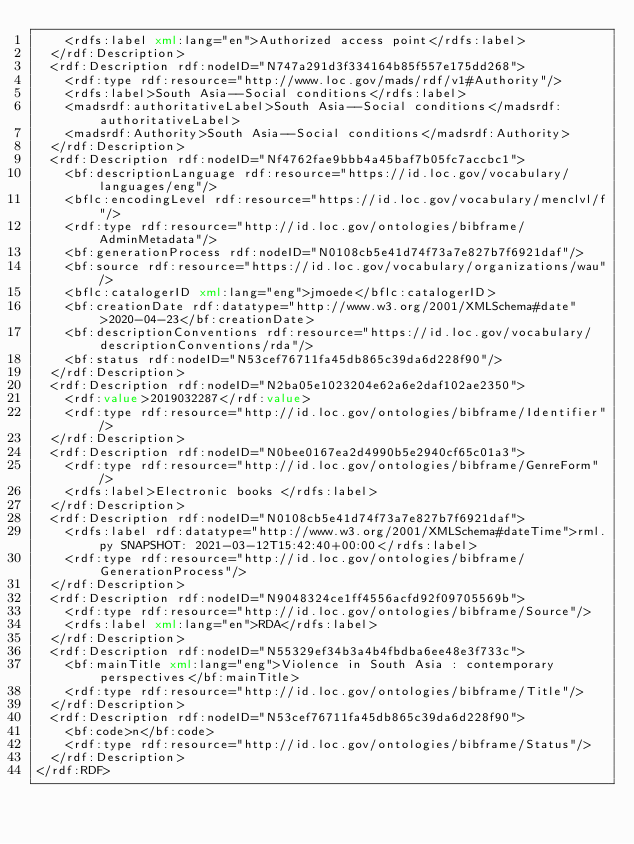<code> <loc_0><loc_0><loc_500><loc_500><_XML_>    <rdfs:label xml:lang="en">Authorized access point</rdfs:label>
  </rdf:Description>
  <rdf:Description rdf:nodeID="N747a291d3f334164b85f557e175dd268">
    <rdf:type rdf:resource="http://www.loc.gov/mads/rdf/v1#Authority"/>
    <rdfs:label>South Asia--Social conditions</rdfs:label>
    <madsrdf:authoritativeLabel>South Asia--Social conditions</madsrdf:authoritativeLabel>
    <madsrdf:Authority>South Asia--Social conditions</madsrdf:Authority>
  </rdf:Description>
  <rdf:Description rdf:nodeID="Nf4762fae9bbb4a45baf7b05fc7accbc1">
    <bf:descriptionLanguage rdf:resource="https://id.loc.gov/vocabulary/languages/eng"/>
    <bflc:encodingLevel rdf:resource="https://id.loc.gov/vocabulary/menclvl/f"/>
    <rdf:type rdf:resource="http://id.loc.gov/ontologies/bibframe/AdminMetadata"/>
    <bf:generationProcess rdf:nodeID="N0108cb5e41d74f73a7e827b7f6921daf"/>
    <bf:source rdf:resource="https://id.loc.gov/vocabulary/organizations/wau"/>
    <bflc:catalogerID xml:lang="eng">jmoede</bflc:catalogerID>
    <bf:creationDate rdf:datatype="http://www.w3.org/2001/XMLSchema#date">2020-04-23</bf:creationDate>
    <bf:descriptionConventions rdf:resource="https://id.loc.gov/vocabulary/descriptionConventions/rda"/>
    <bf:status rdf:nodeID="N53cef76711fa45db865c39da6d228f90"/>
  </rdf:Description>
  <rdf:Description rdf:nodeID="N2ba05e1023204e62a6e2daf102ae2350">
    <rdf:value>2019032287</rdf:value>
    <rdf:type rdf:resource="http://id.loc.gov/ontologies/bibframe/Identifier"/>
  </rdf:Description>
  <rdf:Description rdf:nodeID="N0bee0167ea2d4990b5e2940cf65c01a3">
    <rdf:type rdf:resource="http://id.loc.gov/ontologies/bibframe/GenreForm"/>
    <rdfs:label>Electronic books </rdfs:label>
  </rdf:Description>
  <rdf:Description rdf:nodeID="N0108cb5e41d74f73a7e827b7f6921daf">
    <rdfs:label rdf:datatype="http://www.w3.org/2001/XMLSchema#dateTime">rml.py SNAPSHOT: 2021-03-12T15:42:40+00:00</rdfs:label>
    <rdf:type rdf:resource="http://id.loc.gov/ontologies/bibframe/GenerationProcess"/>
  </rdf:Description>
  <rdf:Description rdf:nodeID="N9048324ce1ff4556acfd92f09705569b">
    <rdf:type rdf:resource="http://id.loc.gov/ontologies/bibframe/Source"/>
    <rdfs:label xml:lang="en">RDA</rdfs:label>
  </rdf:Description>
  <rdf:Description rdf:nodeID="N55329ef34b3a4b4fbdba6ee48e3f733c">
    <bf:mainTitle xml:lang="eng">Violence in South Asia : contemporary perspectives</bf:mainTitle>
    <rdf:type rdf:resource="http://id.loc.gov/ontologies/bibframe/Title"/>
  </rdf:Description>
  <rdf:Description rdf:nodeID="N53cef76711fa45db865c39da6d228f90">
    <bf:code>n</bf:code>
    <rdf:type rdf:resource="http://id.loc.gov/ontologies/bibframe/Status"/>
  </rdf:Description>
</rdf:RDF>
</code> 